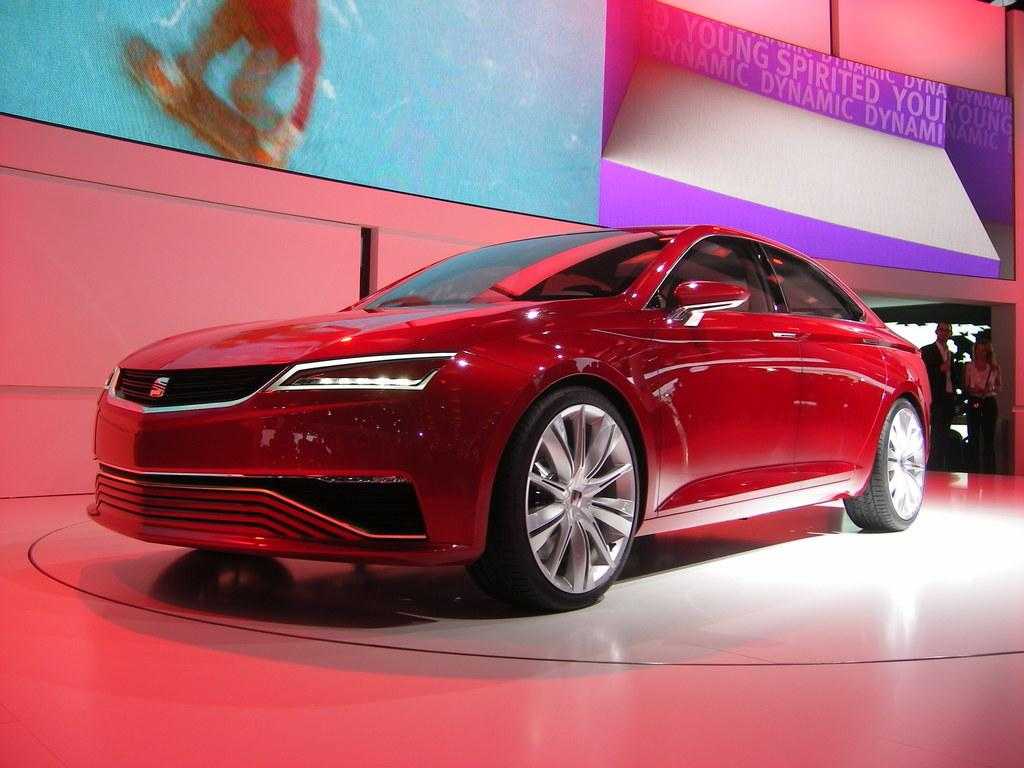What is placed on the floor in the image? There is a car on the floor in the image. Can you describe the people in the background of the image? There are two people standing in the background of the image. What can be seen behind the people in the image? There is a wall visible in the background of the image, along with some objects. What flavor of baseball can be seen in the image? There is no baseball present in the image, so it is not possible to determine the flavor. 